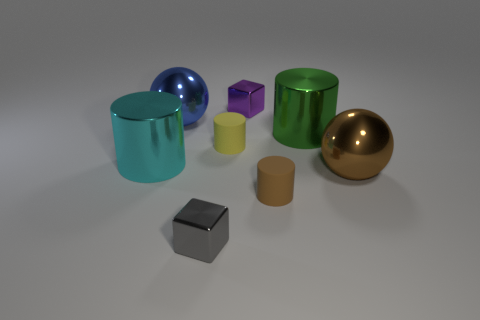What number of other objects are there of the same size as the cyan metal cylinder? There are three other objects of the same size as the cyan metal cylinder. This includes one additional cyan cylinder, and two green cylinders, reflecting an interesting variation in color while maintaining the same size. 